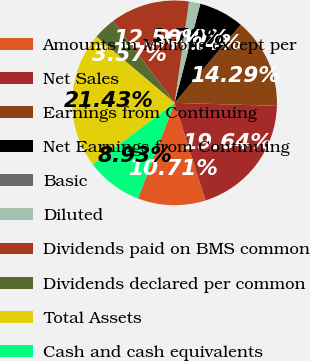Convert chart. <chart><loc_0><loc_0><loc_500><loc_500><pie_chart><fcel>Amounts in Millions except per<fcel>Net Sales<fcel>Earnings from Continuing<fcel>Net Earnings from Continuing<fcel>Basic<fcel>Diluted<fcel>Dividends paid on BMS common<fcel>Dividends declared per common<fcel>Total Assets<fcel>Cash and cash equivalents<nl><fcel>10.71%<fcel>19.64%<fcel>14.29%<fcel>7.14%<fcel>0.0%<fcel>1.79%<fcel>12.5%<fcel>3.57%<fcel>21.43%<fcel>8.93%<nl></chart> 